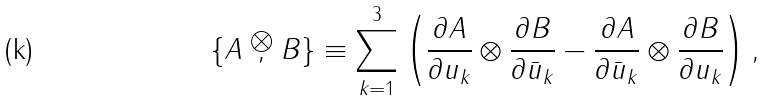Convert formula to latex. <formula><loc_0><loc_0><loc_500><loc_500>\{ A \stackrel { \bigotimes } { , } B \} \equiv \sum _ { k = 1 } ^ { 3 } \left ( \frac { \partial A } { \partial u _ { k } } \otimes \frac { \partial B } { \partial \bar { u } _ { k } } - \frac { \partial A } { \partial \bar { u } _ { k } } \otimes \frac { \partial B } { \partial u _ { k } } \right ) ,</formula> 